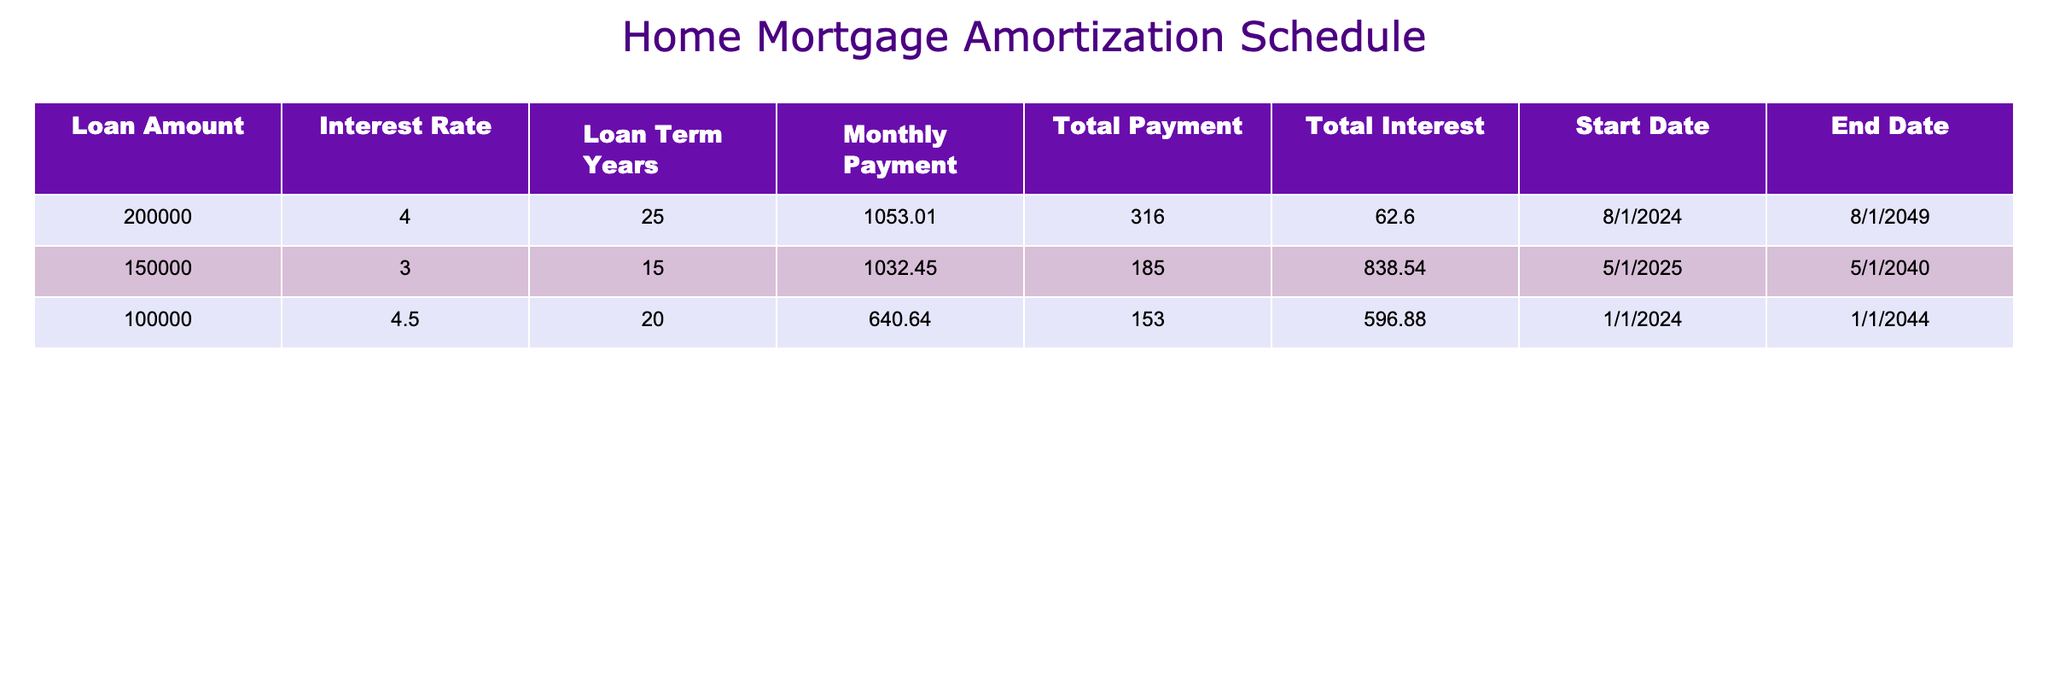What is the total payment for the loan amount of 200,000? The table shows that the total payment for the loan amount of 200,000 is 316,062.60. This value is listed in the row corresponding to this loan amount.
Answer: 316,062.60 What is the monthly payment for the 15-year loan of 150,000? According to the table, the monthly payment for the loan of 150,000, which has a term of 15 years, is 1,032.45. This value is found in the corresponding cell for this loan term.
Answer: 1,032.45 Is the interest rate for the loan with the lowest amount the highest? No, the interest rate for the 100,000 loan is 4.5%, while the 150,000 loan has a lower amount at 3.0%. The loan with the lowest amount does not have the highest interest rate.
Answer: No What is the difference in total payments between the 25-year loan and the 15-year loan? The total payment for the 25-year loan is 316,062.60, and the total payment for the 15-year loan is 185,838.54. The difference is calculated as 316,062.60 - 185,838.54 = 130,224.06.
Answer: 130,224.06 What is the average monthly payment across all loans? The monthly payments are 1,053.01 for the 25-year loan, 1,032.45 for the 15-year loan, and 640.64 for the 20-year loan. The sum of the payments is 1,053.01 + 1,032.45 + 640.64 = 2,726.10. There are 3 loans, so the average is 2,726.10 / 3 = 908.70.
Answer: 908.70 In how many years does the loan of 100,000 end? The table indicates that the loan of 100,000 has an end date of 1/1/2044. Given it starts on 1/1/2024, this is a period of 20 years until it ends.
Answer: 20 Which loan has the highest total interest paid? The loan of 200,000 has the highest total interest paid, which is indicated as not directly in the rows but can be inferred from the comparison of total interest values. The other loans have lower total interest values.
Answer: 200,000 loan What is the total interest paid for the loan of 100,000? The table shows that the total interest paid for the loan amount of 100,000 is 53,596.88. This information is provided directly in the table for this loan amount.
Answer: 53,596.88 